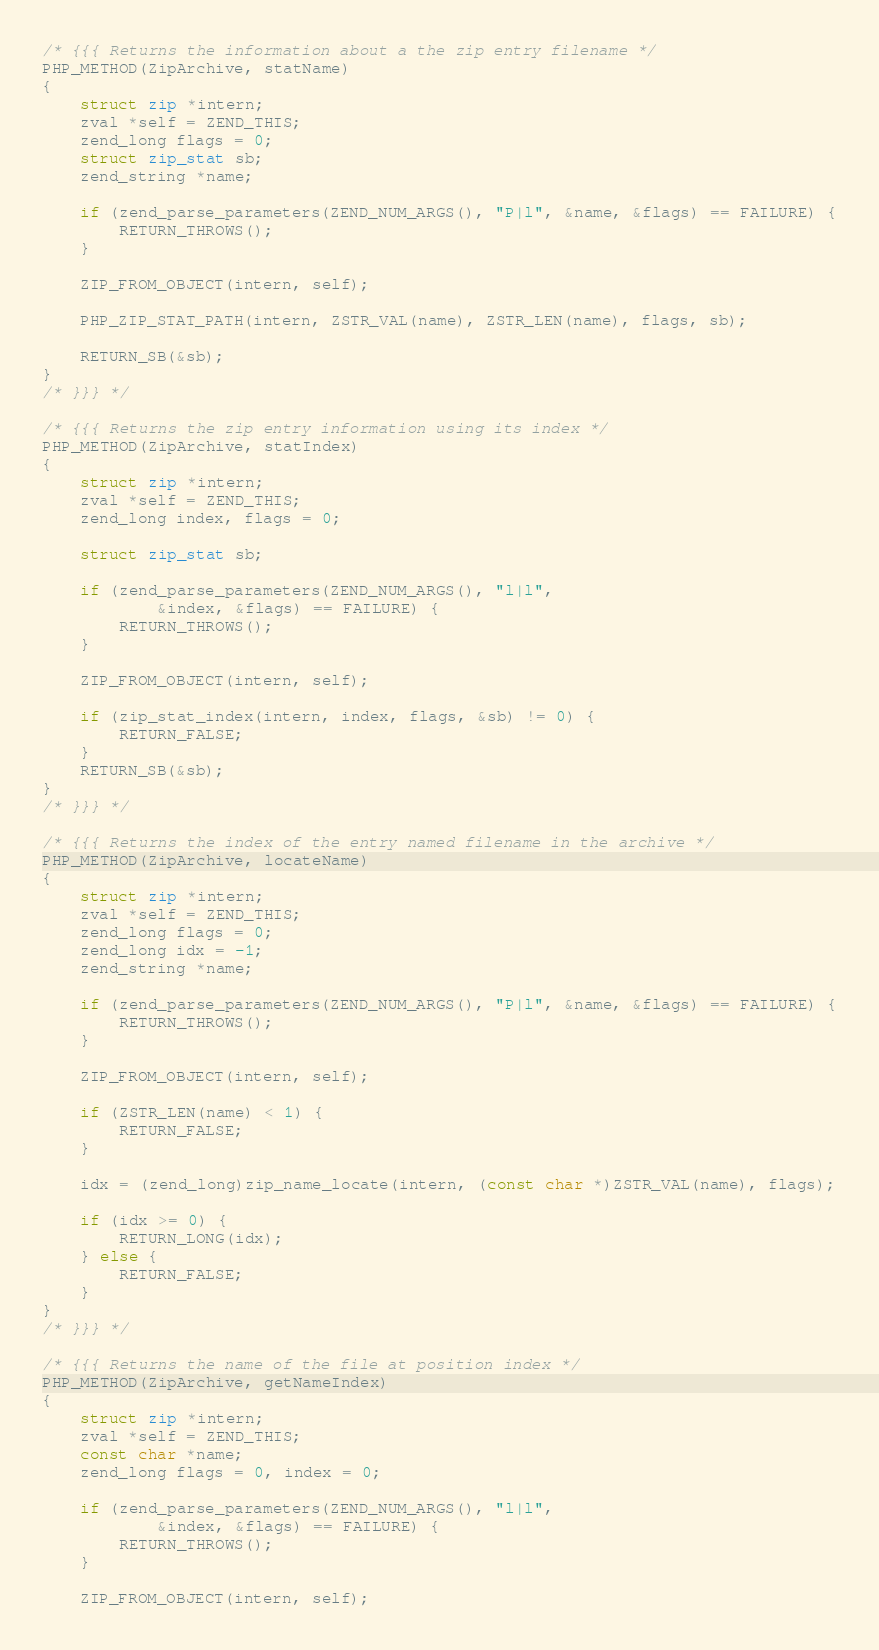<code> <loc_0><loc_0><loc_500><loc_500><_C_>/* {{{ Returns the information about a the zip entry filename */
PHP_METHOD(ZipArchive, statName)
{
	struct zip *intern;
	zval *self = ZEND_THIS;
	zend_long flags = 0;
	struct zip_stat sb;
	zend_string *name;

	if (zend_parse_parameters(ZEND_NUM_ARGS(), "P|l", &name, &flags) == FAILURE) {
		RETURN_THROWS();
	}

	ZIP_FROM_OBJECT(intern, self);

	PHP_ZIP_STAT_PATH(intern, ZSTR_VAL(name), ZSTR_LEN(name), flags, sb);

	RETURN_SB(&sb);
}
/* }}} */

/* {{{ Returns the zip entry information using its index */
PHP_METHOD(ZipArchive, statIndex)
{
	struct zip *intern;
	zval *self = ZEND_THIS;
	zend_long index, flags = 0;

	struct zip_stat sb;

	if (zend_parse_parameters(ZEND_NUM_ARGS(), "l|l",
			&index, &flags) == FAILURE) {
		RETURN_THROWS();
	}

	ZIP_FROM_OBJECT(intern, self);

	if (zip_stat_index(intern, index, flags, &sb) != 0) {
		RETURN_FALSE;
	}
	RETURN_SB(&sb);
}
/* }}} */

/* {{{ Returns the index of the entry named filename in the archive */
PHP_METHOD(ZipArchive, locateName)
{
	struct zip *intern;
	zval *self = ZEND_THIS;
	zend_long flags = 0;
	zend_long idx = -1;
	zend_string *name;

	if (zend_parse_parameters(ZEND_NUM_ARGS(), "P|l", &name, &flags) == FAILURE) {
		RETURN_THROWS();
	}

	ZIP_FROM_OBJECT(intern, self);

	if (ZSTR_LEN(name) < 1) {
		RETURN_FALSE;
	}

	idx = (zend_long)zip_name_locate(intern, (const char *)ZSTR_VAL(name), flags);

	if (idx >= 0) {
		RETURN_LONG(idx);
	} else {
		RETURN_FALSE;
	}
}
/* }}} */

/* {{{ Returns the name of the file at position index */
PHP_METHOD(ZipArchive, getNameIndex)
{
	struct zip *intern;
	zval *self = ZEND_THIS;
	const char *name;
	zend_long flags = 0, index = 0;

	if (zend_parse_parameters(ZEND_NUM_ARGS(), "l|l",
			&index, &flags) == FAILURE) {
		RETURN_THROWS();
	}

	ZIP_FROM_OBJECT(intern, self);
</code> 